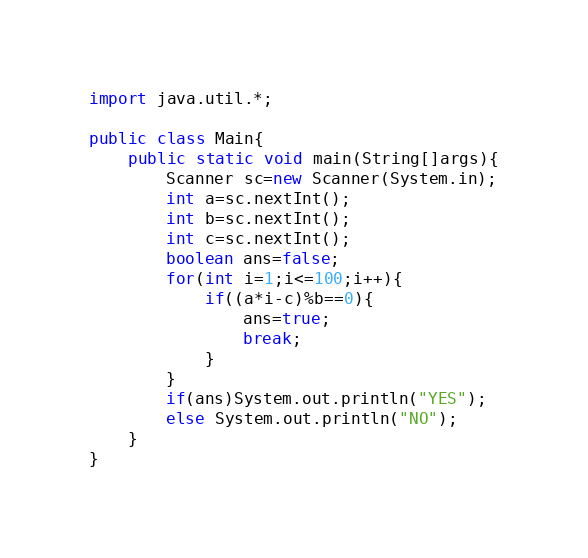Convert code to text. <code><loc_0><loc_0><loc_500><loc_500><_Java_>import java.util.*;

public class Main{
    public static void main(String[]args){
        Scanner sc=new Scanner(System.in);
        int a=sc.nextInt();
        int b=sc.nextInt();
        int c=sc.nextInt();
        boolean ans=false;
        for(int i=1;i<=100;i++){
            if((a*i-c)%b==0){
                ans=true;
                break;
            }
        }
        if(ans)System.out.println("YES");
        else System.out.println("NO");
    }
}</code> 